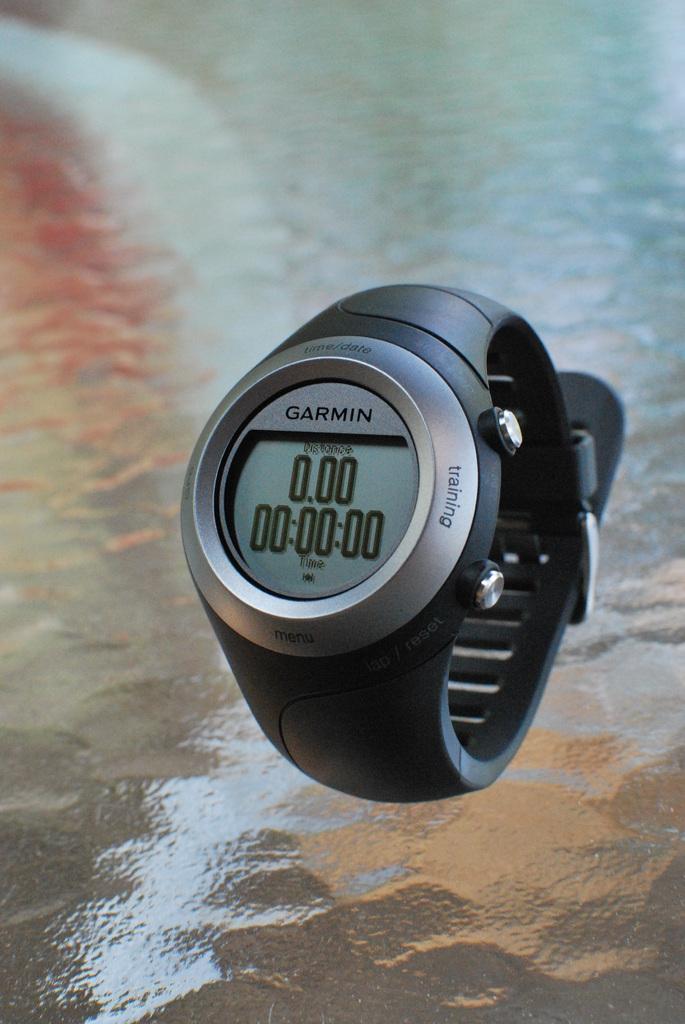What brand of watch is this?
Offer a very short reply. Garmin. What number is repeated on the watch?
Your response must be concise. 0. 